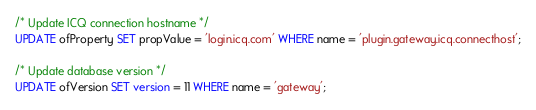Convert code to text. <code><loc_0><loc_0><loc_500><loc_500><_SQL_>/* Update ICQ connection hostname */
UPDATE ofProperty SET propValue = 'login.icq.com' WHERE name = 'plugin.gateway.icq.connecthost';

/* Update database version */
UPDATE ofVersion SET version = 11 WHERE name = 'gateway';
</code> 